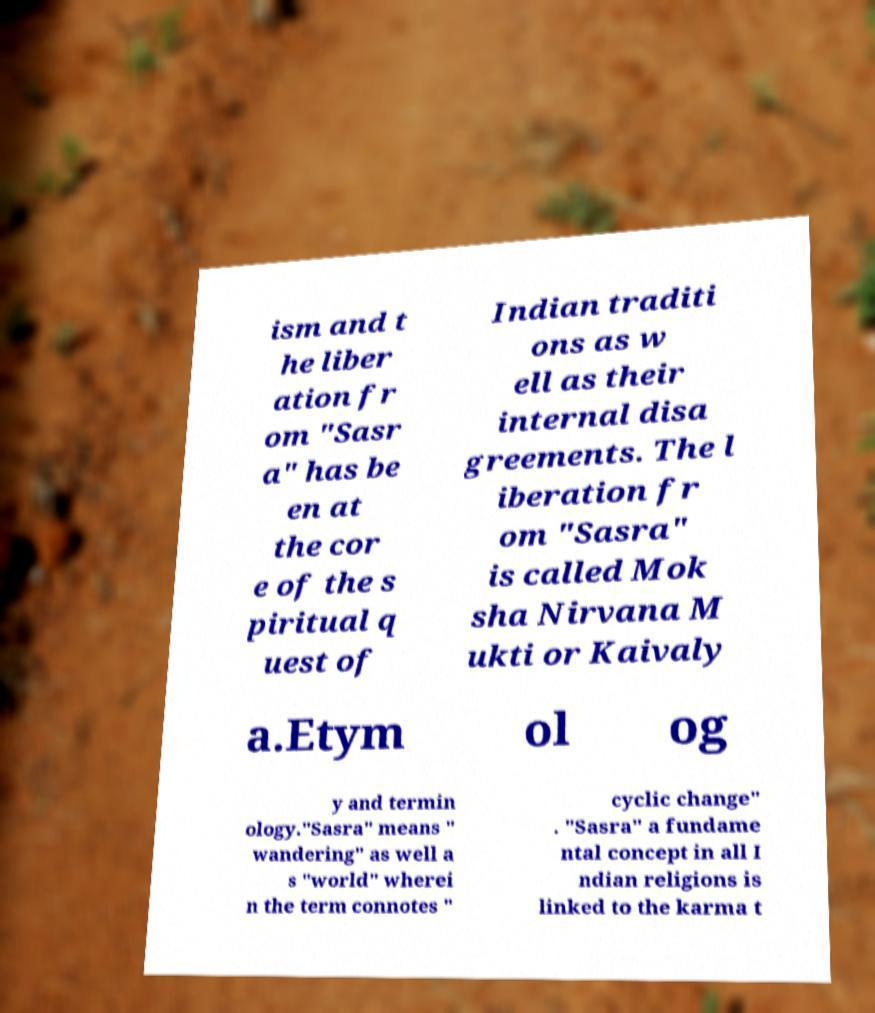What messages or text are displayed in this image? I need them in a readable, typed format. ism and t he liber ation fr om "Sasr a" has be en at the cor e of the s piritual q uest of Indian traditi ons as w ell as their internal disa greements. The l iberation fr om "Sasra" is called Mok sha Nirvana M ukti or Kaivaly a.Etym ol og y and termin ology."Sasra" means " wandering" as well a s "world" wherei n the term connotes " cyclic change" . "Sasra" a fundame ntal concept in all I ndian religions is linked to the karma t 